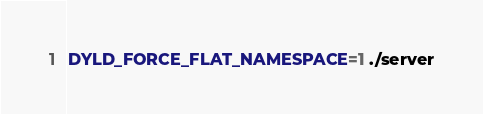<code> <loc_0><loc_0><loc_500><loc_500><_Bash_>DYLD_FORCE_FLAT_NAMESPACE=1 ./server
</code> 